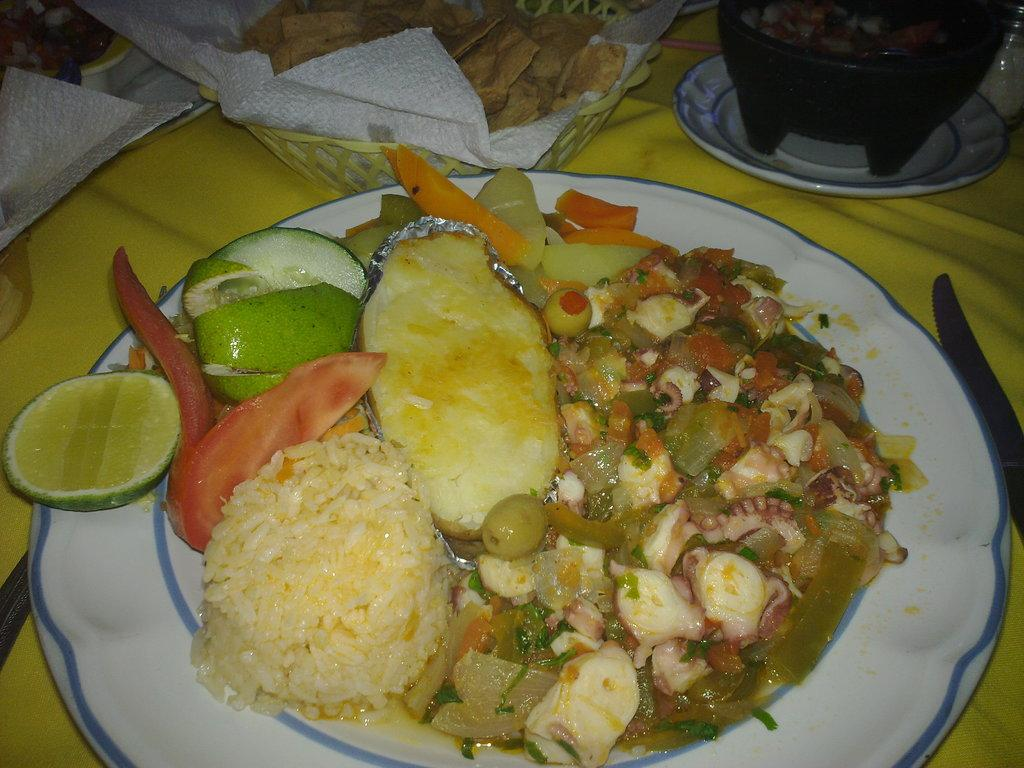What utensil can be seen in the image? There is a knife in the image. What objects are used for serving or holding food in the image? There are plates and a bowl in the image. What can be found on the plates and in the bowl? There are food items in the image. Where might this image have been taken? The image is likely taken in a house. What type of apparatus is being used to turn the pages of the map in the image? There is no apparatus, pages, or map present in the image. 